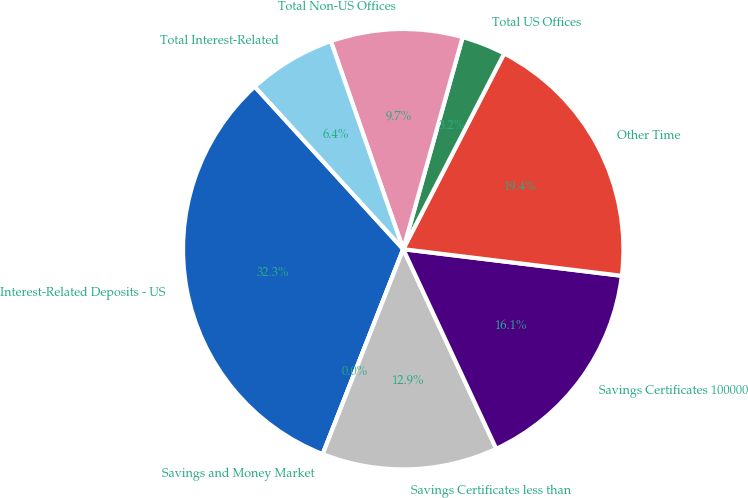Convert chart to OTSL. <chart><loc_0><loc_0><loc_500><loc_500><pie_chart><fcel>Interest-Related Deposits - US<fcel>Savings and Money Market<fcel>Savings Certificates less than<fcel>Savings Certificates 100000<fcel>Other Time<fcel>Total US Offices<fcel>Total Non-US Offices<fcel>Total Interest-Related<nl><fcel>32.26%<fcel>0.0%<fcel>12.9%<fcel>16.13%<fcel>19.35%<fcel>3.23%<fcel>9.68%<fcel>6.45%<nl></chart> 